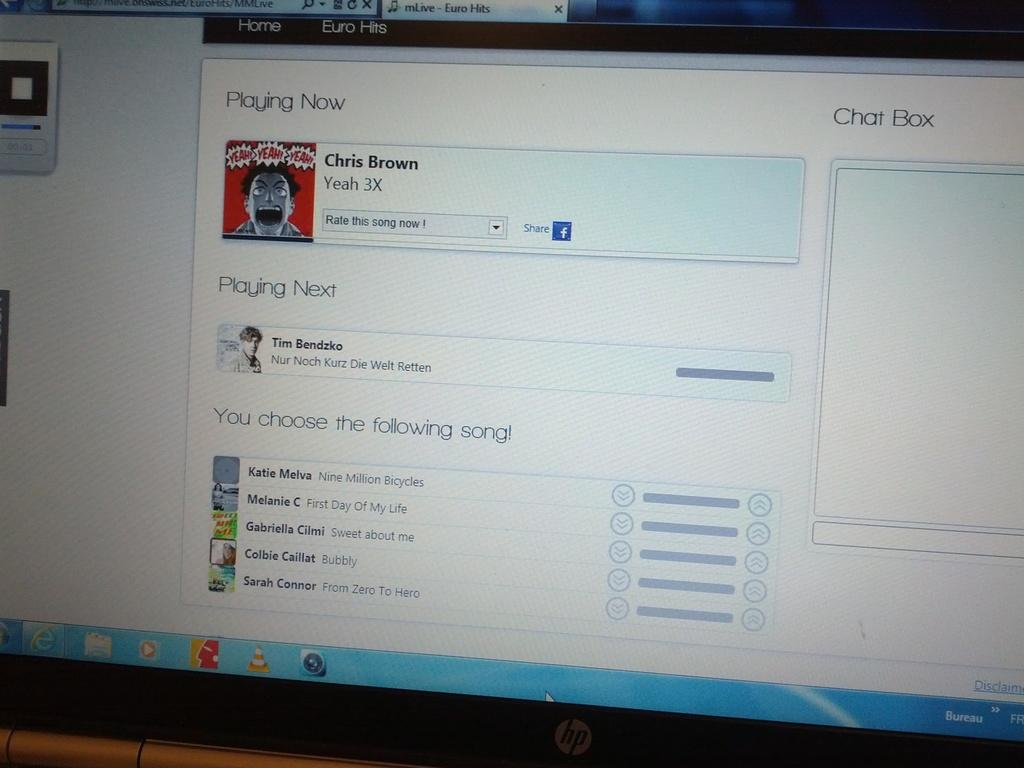Provide a one-sentence caption for the provided image. An HP monitor shows a chat box and a facebook share button. 